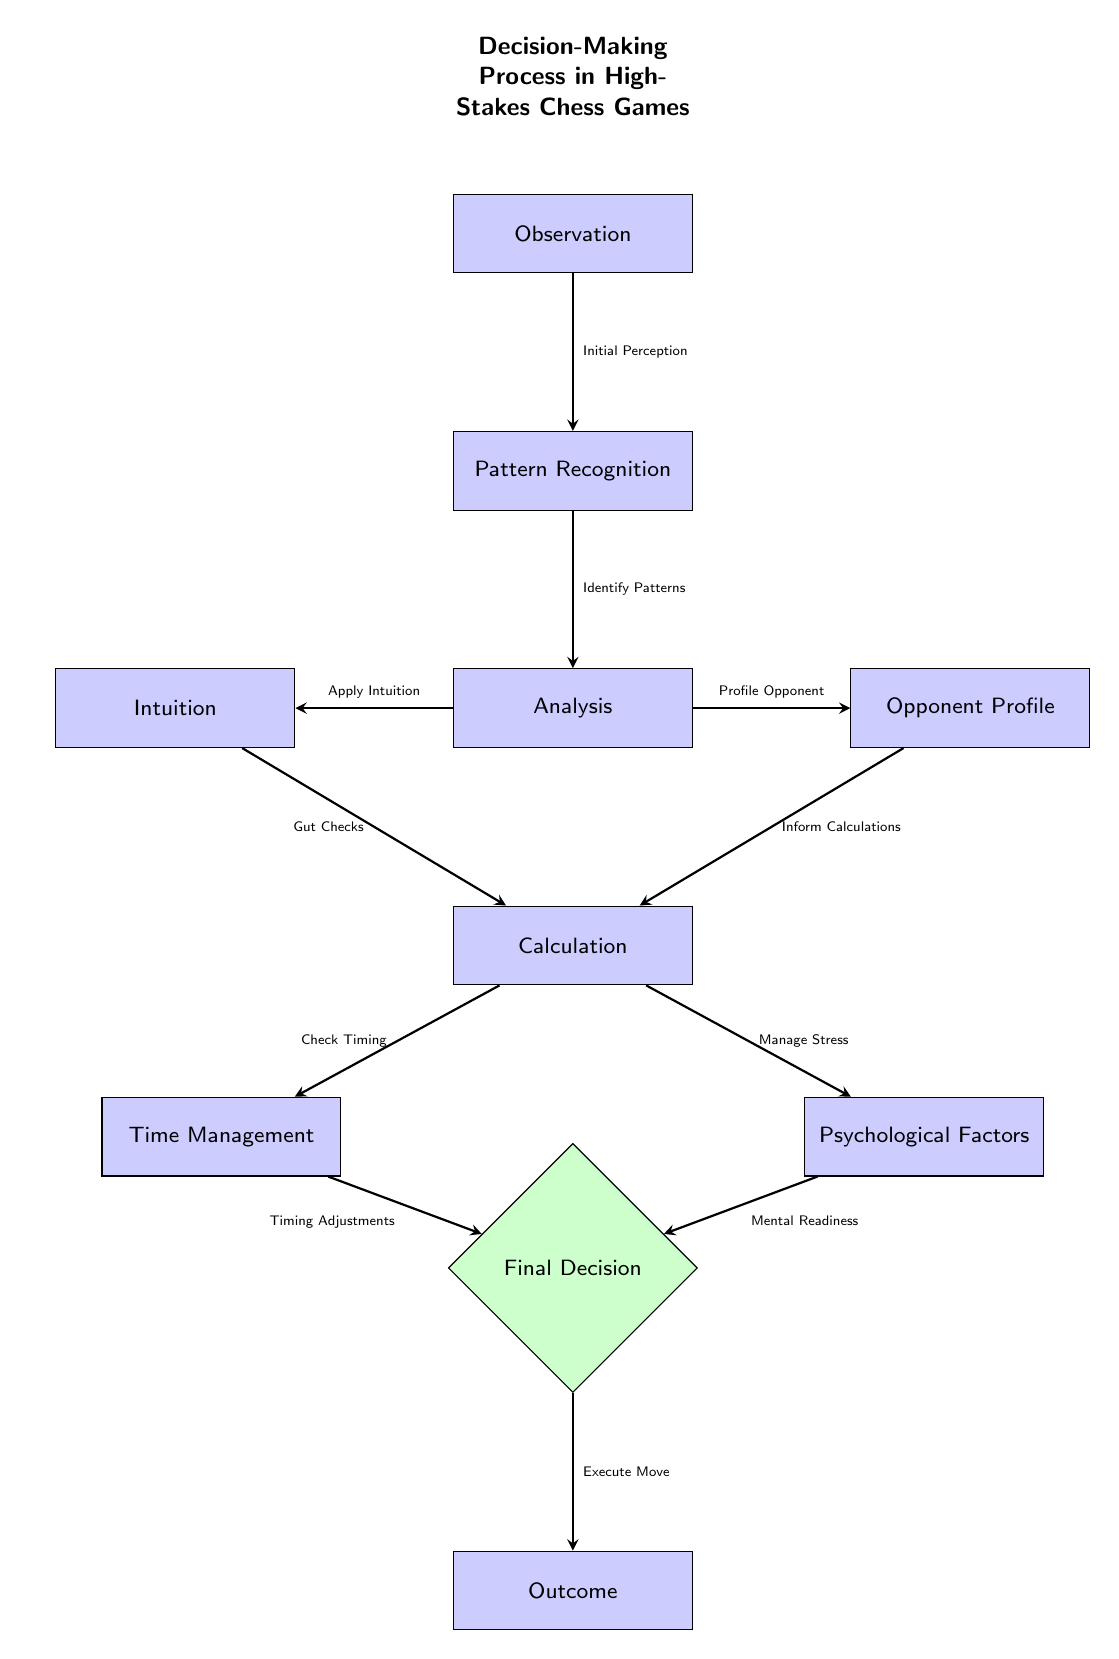What is the first step in the decision-making process? The diagram indicates that "Observation" is the first step, as it is the top node before any other processes are initiated.
Answer: Observation How many decision nodes are present in the diagram? The diagram contains one decision node identified as "Final Decision," which guides the process toward outcomes.
Answer: 1 What influences the calculations made by chess players? According to the diagram, "Opponent Profile" is one of the influences that inform the calculations chess players make during their decision-making process.
Answer: Opponent Profile What is the relationship between the analysis and intuition nodes? The analysis node is linked to the intuition node; specifically, the flow shows that from "Analysis," players apply "Intuition" as part of their decision-making approach.
Answer: Apply Intuition What factors contribute to the final decision? The final decision is influenced by both "Time Management" and "Psychological Factors," which must be considered before executing the move.
Answer: Time Management, Psychological Factors What type of factors does the 'calculation' node rely on? The 'calculation' node relies on both the "Opponent Profile" for informing calculations and "Intuition" for gut checks, indicating a need for both analytical and instinctual input.
Answer: Opponent Profile, Intuition Where does the initial perception lead to in the decision-making process? The "Initial Perception" from the observation leads to the next step, which is "Pattern Recognition;” this is sequentially the first action taken in the decision-making flow.
Answer: Pattern Recognition What is the final outcome of the decision-making process? The final outcome described in the diagram is "Outcome," indicating that the result of the decision is determined after executing the move.
Answer: Outcome What is the primary focus at the "Psychological Factors" node? The focus at the "Psychological Factors" node is primarily on "Mental Readiness," which is crucial in managing the player's stress and overall psychological state.
Answer: Mental Readiness 